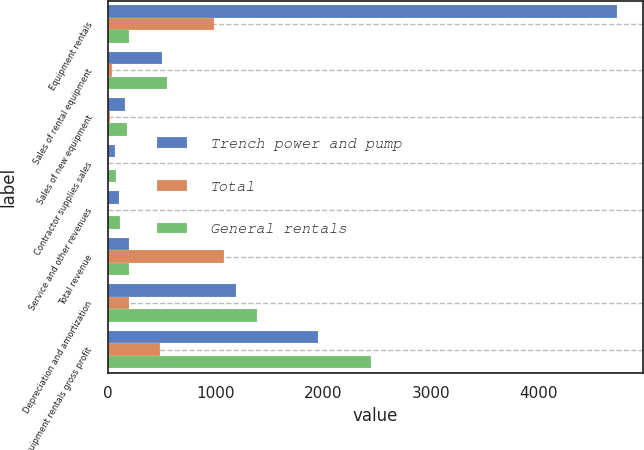Convert chart. <chart><loc_0><loc_0><loc_500><loc_500><stacked_bar_chart><ecel><fcel>Equipment rentals<fcel>Sales of rental equipment<fcel>Sales of new equipment<fcel>Contractor supplies sales<fcel>Service and other revenues<fcel>Total revenue<fcel>Depreciation and amortization<fcel>Equipment rentals gross profit<nl><fcel>Trench power and pump<fcel>4727<fcel>509<fcel>159<fcel>65<fcel>105<fcel>195<fcel>1188<fcel>1950<nl><fcel>Total<fcel>988<fcel>41<fcel>19<fcel>15<fcel>13<fcel>1076<fcel>195<fcel>490<nl><fcel>General rentals<fcel>195<fcel>550<fcel>178<fcel>80<fcel>118<fcel>195<fcel>1383<fcel>2440<nl></chart> 